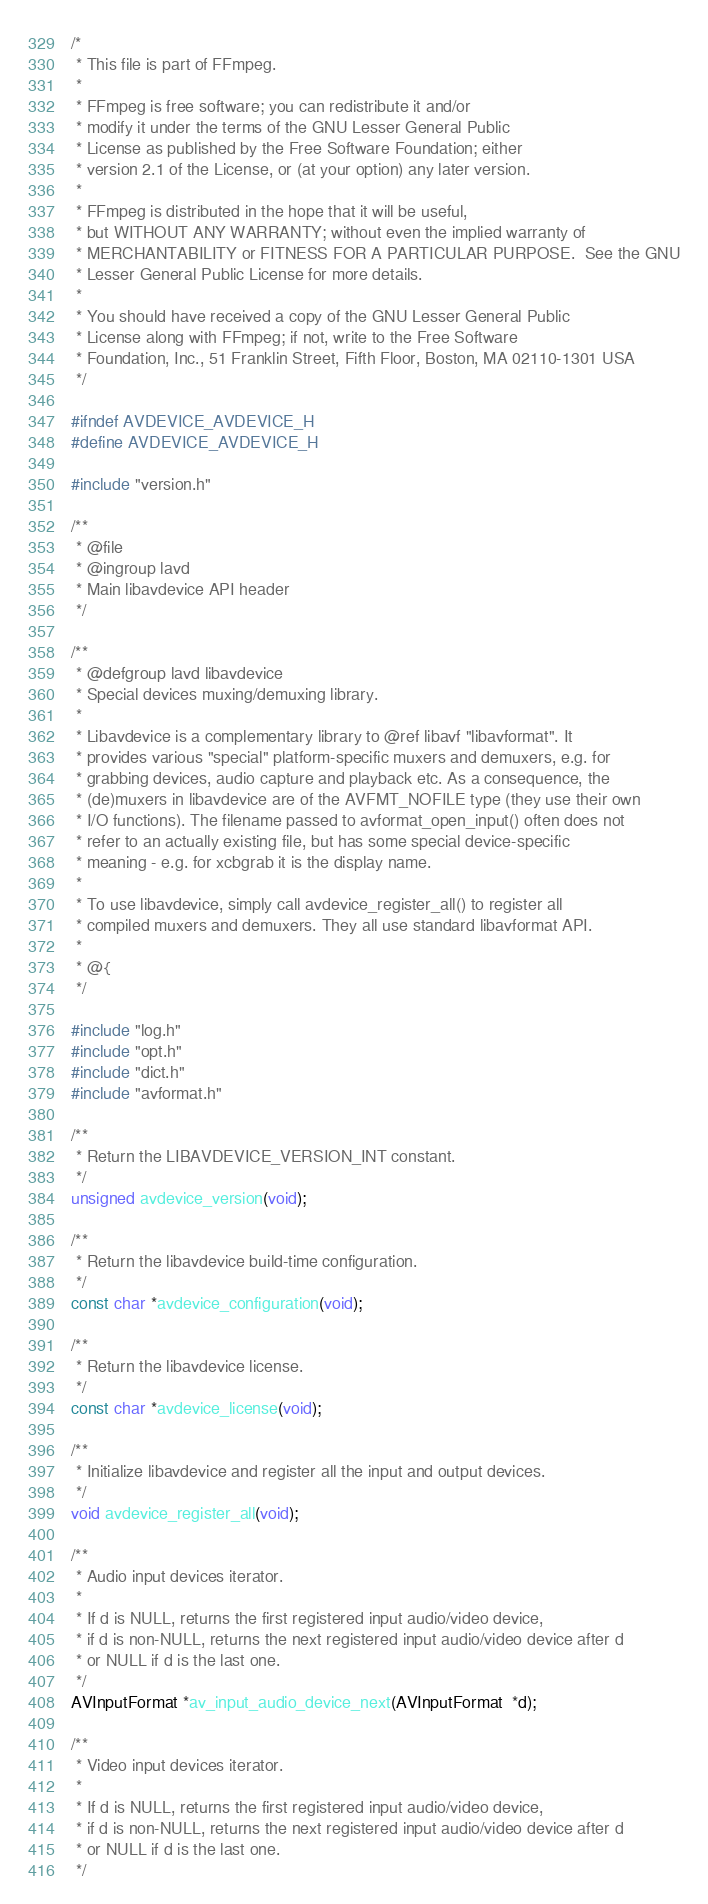<code> <loc_0><loc_0><loc_500><loc_500><_C_>/*
 * This file is part of FFmpeg.
 *
 * FFmpeg is free software; you can redistribute it and/or
 * modify it under the terms of the GNU Lesser General Public
 * License as published by the Free Software Foundation; either
 * version 2.1 of the License, or (at your option) any later version.
 *
 * FFmpeg is distributed in the hope that it will be useful,
 * but WITHOUT ANY WARRANTY; without even the implied warranty of
 * MERCHANTABILITY or FITNESS FOR A PARTICULAR PURPOSE.  See the GNU
 * Lesser General Public License for more details.
 *
 * You should have received a copy of the GNU Lesser General Public
 * License along with FFmpeg; if not, write to the Free Software
 * Foundation, Inc., 51 Franklin Street, Fifth Floor, Boston, MA 02110-1301 USA
 */

#ifndef AVDEVICE_AVDEVICE_H
#define AVDEVICE_AVDEVICE_H

#include "version.h"

/**
 * @file
 * @ingroup lavd
 * Main libavdevice API header
 */

/**
 * @defgroup lavd libavdevice
 * Special devices muxing/demuxing library.
 *
 * Libavdevice is a complementary library to @ref libavf "libavformat". It
 * provides various "special" platform-specific muxers and demuxers, e.g. for
 * grabbing devices, audio capture and playback etc. As a consequence, the
 * (de)muxers in libavdevice are of the AVFMT_NOFILE type (they use their own
 * I/O functions). The filename passed to avformat_open_input() often does not
 * refer to an actually existing file, but has some special device-specific
 * meaning - e.g. for xcbgrab it is the display name.
 *
 * To use libavdevice, simply call avdevice_register_all() to register all
 * compiled muxers and demuxers. They all use standard libavformat API.
 *
 * @{
 */

#include "log.h"
#include "opt.h"
#include "dict.h"
#include "avformat.h"

/**
 * Return the LIBAVDEVICE_VERSION_INT constant.
 */
unsigned avdevice_version(void);

/**
 * Return the libavdevice build-time configuration.
 */
const char *avdevice_configuration(void);

/**
 * Return the libavdevice license.
 */
const char *avdevice_license(void);

/**
 * Initialize libavdevice and register all the input and output devices.
 */
void avdevice_register_all(void);

/**
 * Audio input devices iterator.
 *
 * If d is NULL, returns the first registered input audio/video device,
 * if d is non-NULL, returns the next registered input audio/video device after d
 * or NULL if d is the last one.
 */
AVInputFormat *av_input_audio_device_next(AVInputFormat  *d);

/**
 * Video input devices iterator.
 *
 * If d is NULL, returns the first registered input audio/video device,
 * if d is non-NULL, returns the next registered input audio/video device after d
 * or NULL if d is the last one.
 */</code> 